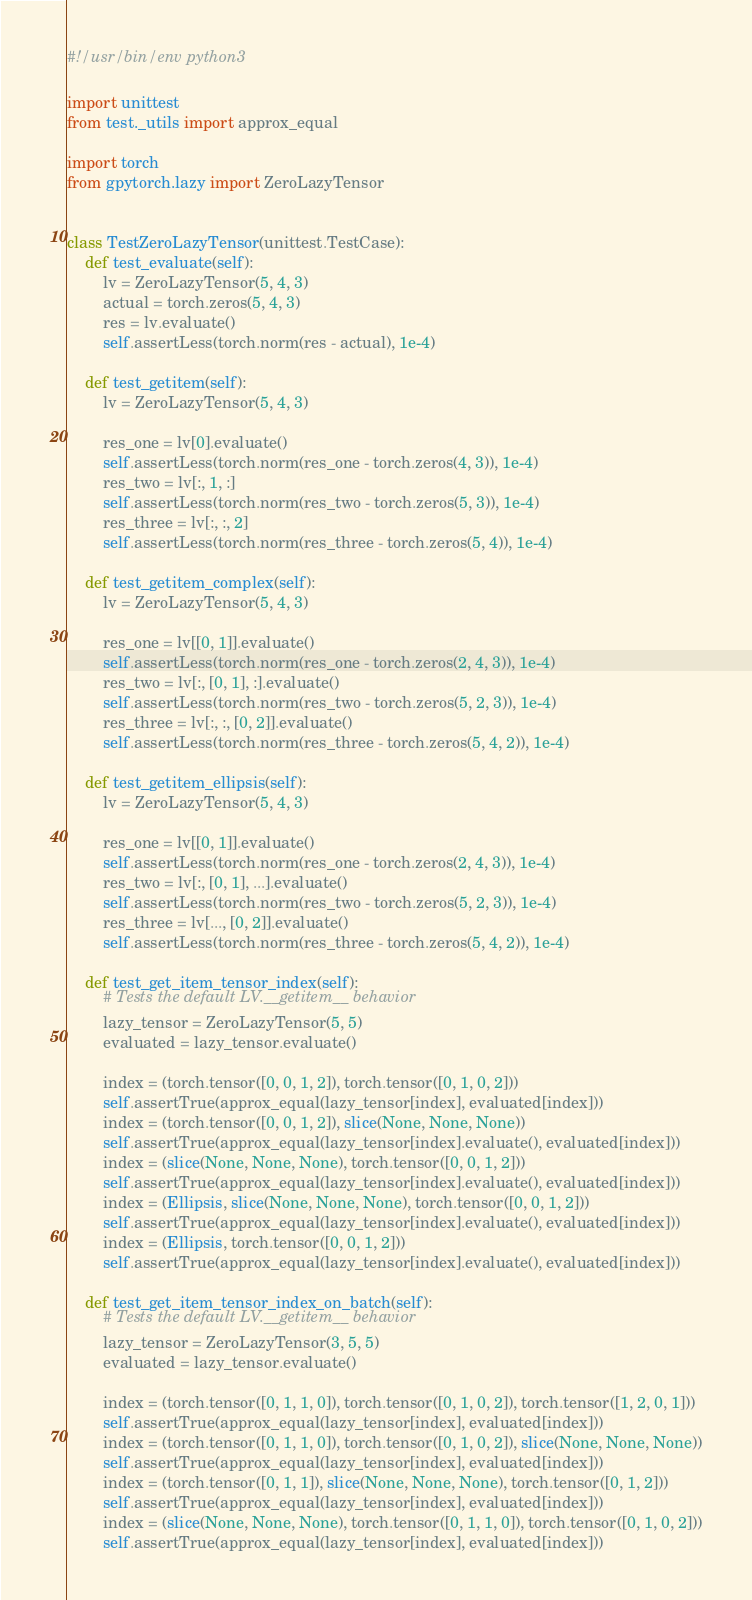Convert code to text. <code><loc_0><loc_0><loc_500><loc_500><_Python_>#!/usr/bin/env python3

import unittest
from test._utils import approx_equal

import torch
from gpytorch.lazy import ZeroLazyTensor


class TestZeroLazyTensor(unittest.TestCase):
    def test_evaluate(self):
        lv = ZeroLazyTensor(5, 4, 3)
        actual = torch.zeros(5, 4, 3)
        res = lv.evaluate()
        self.assertLess(torch.norm(res - actual), 1e-4)

    def test_getitem(self):
        lv = ZeroLazyTensor(5, 4, 3)

        res_one = lv[0].evaluate()
        self.assertLess(torch.norm(res_one - torch.zeros(4, 3)), 1e-4)
        res_two = lv[:, 1, :]
        self.assertLess(torch.norm(res_two - torch.zeros(5, 3)), 1e-4)
        res_three = lv[:, :, 2]
        self.assertLess(torch.norm(res_three - torch.zeros(5, 4)), 1e-4)

    def test_getitem_complex(self):
        lv = ZeroLazyTensor(5, 4, 3)

        res_one = lv[[0, 1]].evaluate()
        self.assertLess(torch.norm(res_one - torch.zeros(2, 4, 3)), 1e-4)
        res_two = lv[:, [0, 1], :].evaluate()
        self.assertLess(torch.norm(res_two - torch.zeros(5, 2, 3)), 1e-4)
        res_three = lv[:, :, [0, 2]].evaluate()
        self.assertLess(torch.norm(res_three - torch.zeros(5, 4, 2)), 1e-4)

    def test_getitem_ellipsis(self):
        lv = ZeroLazyTensor(5, 4, 3)

        res_one = lv[[0, 1]].evaluate()
        self.assertLess(torch.norm(res_one - torch.zeros(2, 4, 3)), 1e-4)
        res_two = lv[:, [0, 1], ...].evaluate()
        self.assertLess(torch.norm(res_two - torch.zeros(5, 2, 3)), 1e-4)
        res_three = lv[..., [0, 2]].evaluate()
        self.assertLess(torch.norm(res_three - torch.zeros(5, 4, 2)), 1e-4)

    def test_get_item_tensor_index(self):
        # Tests the default LV.__getitem__ behavior
        lazy_tensor = ZeroLazyTensor(5, 5)
        evaluated = lazy_tensor.evaluate()

        index = (torch.tensor([0, 0, 1, 2]), torch.tensor([0, 1, 0, 2]))
        self.assertTrue(approx_equal(lazy_tensor[index], evaluated[index]))
        index = (torch.tensor([0, 0, 1, 2]), slice(None, None, None))
        self.assertTrue(approx_equal(lazy_tensor[index].evaluate(), evaluated[index]))
        index = (slice(None, None, None), torch.tensor([0, 0, 1, 2]))
        self.assertTrue(approx_equal(lazy_tensor[index].evaluate(), evaluated[index]))
        index = (Ellipsis, slice(None, None, None), torch.tensor([0, 0, 1, 2]))
        self.assertTrue(approx_equal(lazy_tensor[index].evaluate(), evaluated[index]))
        index = (Ellipsis, torch.tensor([0, 0, 1, 2]))
        self.assertTrue(approx_equal(lazy_tensor[index].evaluate(), evaluated[index]))

    def test_get_item_tensor_index_on_batch(self):
        # Tests the default LV.__getitem__ behavior
        lazy_tensor = ZeroLazyTensor(3, 5, 5)
        evaluated = lazy_tensor.evaluate()

        index = (torch.tensor([0, 1, 1, 0]), torch.tensor([0, 1, 0, 2]), torch.tensor([1, 2, 0, 1]))
        self.assertTrue(approx_equal(lazy_tensor[index], evaluated[index]))
        index = (torch.tensor([0, 1, 1, 0]), torch.tensor([0, 1, 0, 2]), slice(None, None, None))
        self.assertTrue(approx_equal(lazy_tensor[index], evaluated[index]))
        index = (torch.tensor([0, 1, 1]), slice(None, None, None), torch.tensor([0, 1, 2]))
        self.assertTrue(approx_equal(lazy_tensor[index], evaluated[index]))
        index = (slice(None, None, None), torch.tensor([0, 1, 1, 0]), torch.tensor([0, 1, 0, 2]))
        self.assertTrue(approx_equal(lazy_tensor[index], evaluated[index]))</code> 